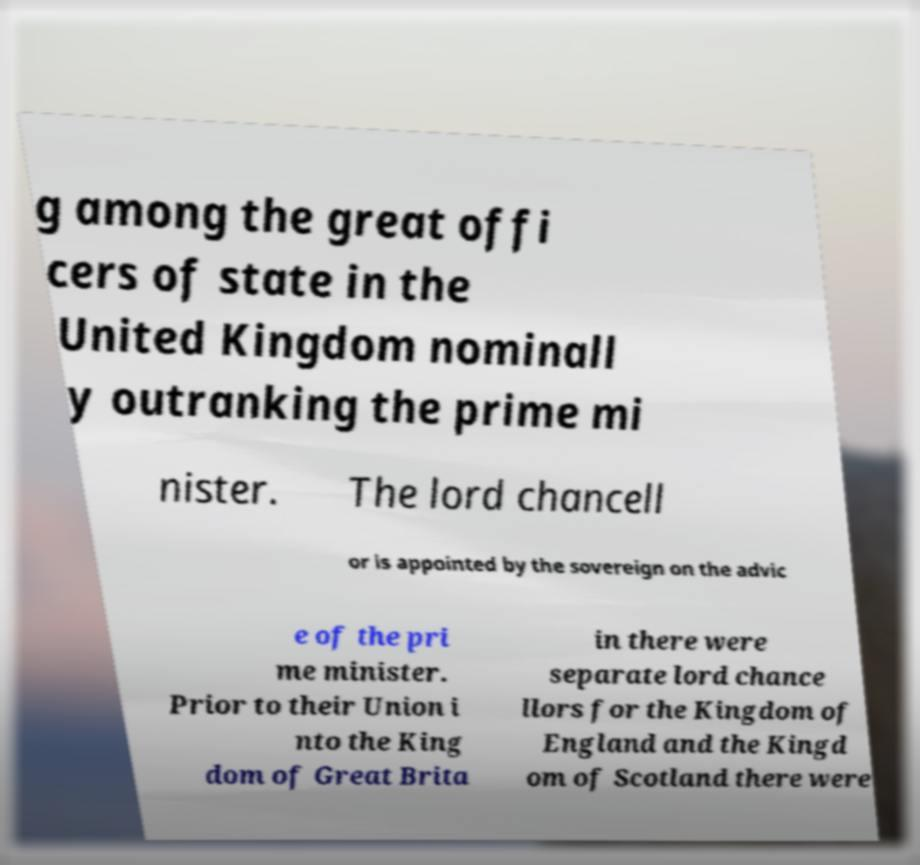Can you accurately transcribe the text from the provided image for me? g among the great offi cers of state in the United Kingdom nominall y outranking the prime mi nister. The lord chancell or is appointed by the sovereign on the advic e of the pri me minister. Prior to their Union i nto the King dom of Great Brita in there were separate lord chance llors for the Kingdom of England and the Kingd om of Scotland there were 